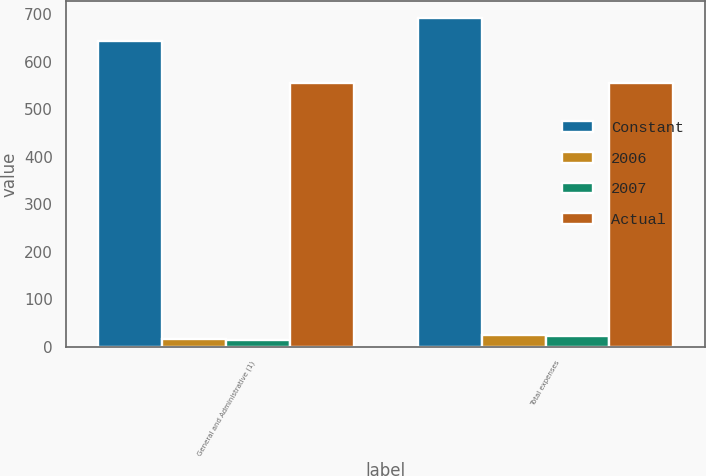<chart> <loc_0><loc_0><loc_500><loc_500><stacked_bar_chart><ecel><fcel>General and Administrative (1)<fcel>Total expenses<nl><fcel>Constant<fcel>643<fcel>692<nl><fcel>2006<fcel>16<fcel>25<nl><fcel>2007<fcel>13<fcel>22<nl><fcel>Actual<fcel>555<fcel>555<nl></chart> 